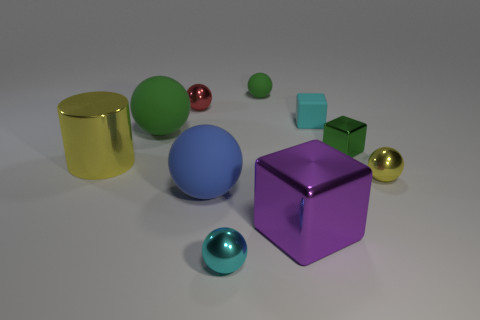Subtract all cyan blocks. How many blocks are left? 2 Subtract all green cubes. How many cubes are left? 2 Subtract all spheres. How many objects are left? 4 Subtract 1 cylinders. How many cylinders are left? 0 Subtract all small red metallic balls. Subtract all small cubes. How many objects are left? 7 Add 9 cylinders. How many cylinders are left? 10 Add 3 tiny blue metallic objects. How many tiny blue metallic objects exist? 3 Subtract 0 blue cylinders. How many objects are left? 10 Subtract all red spheres. Subtract all green cylinders. How many spheres are left? 5 Subtract all blue balls. How many purple cubes are left? 1 